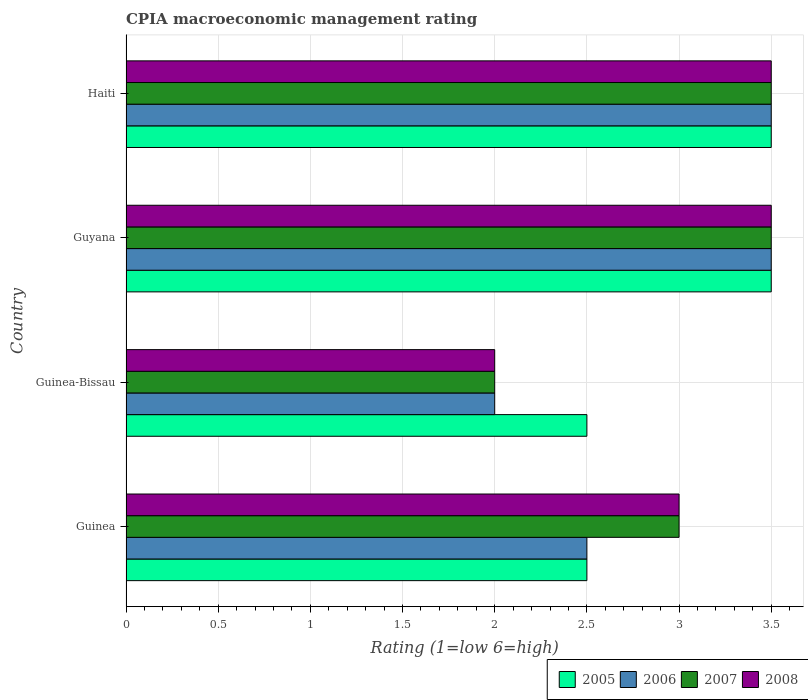How many different coloured bars are there?
Give a very brief answer. 4. Are the number of bars on each tick of the Y-axis equal?
Provide a short and direct response. Yes. How many bars are there on the 1st tick from the top?
Offer a very short reply. 4. How many bars are there on the 3rd tick from the bottom?
Keep it short and to the point. 4. What is the label of the 3rd group of bars from the top?
Provide a short and direct response. Guinea-Bissau. Across all countries, what is the minimum CPIA rating in 2005?
Your answer should be compact. 2.5. In which country was the CPIA rating in 2006 maximum?
Offer a terse response. Guyana. In which country was the CPIA rating in 2008 minimum?
Keep it short and to the point. Guinea-Bissau. What is the total CPIA rating in 2008 in the graph?
Make the answer very short. 12. What is the difference between the CPIA rating in 2005 in Guinea-Bissau and that in Haiti?
Keep it short and to the point. -1. What is the average CPIA rating in 2006 per country?
Provide a succinct answer. 2.88. What is the ratio of the CPIA rating in 2007 in Guinea to that in Guyana?
Provide a succinct answer. 0.86. What is the difference between the highest and the lowest CPIA rating in 2007?
Offer a very short reply. 1.5. In how many countries, is the CPIA rating in 2005 greater than the average CPIA rating in 2005 taken over all countries?
Provide a short and direct response. 2. Is the sum of the CPIA rating in 2007 in Guinea and Guinea-Bissau greater than the maximum CPIA rating in 2005 across all countries?
Your answer should be compact. Yes. Is it the case that in every country, the sum of the CPIA rating in 2005 and CPIA rating in 2007 is greater than the sum of CPIA rating in 2008 and CPIA rating in 2006?
Ensure brevity in your answer.  No. What is the difference between two consecutive major ticks on the X-axis?
Your answer should be very brief. 0.5. Does the graph contain any zero values?
Keep it short and to the point. No. Does the graph contain grids?
Keep it short and to the point. Yes. Where does the legend appear in the graph?
Make the answer very short. Bottom right. What is the title of the graph?
Ensure brevity in your answer.  CPIA macroeconomic management rating. What is the label or title of the Y-axis?
Your answer should be very brief. Country. What is the Rating (1=low 6=high) in 2005 in Guinea?
Make the answer very short. 2.5. What is the Rating (1=low 6=high) of 2006 in Guinea?
Offer a terse response. 2.5. What is the Rating (1=low 6=high) in 2007 in Guinea?
Give a very brief answer. 3. What is the Rating (1=low 6=high) of 2006 in Guinea-Bissau?
Your answer should be very brief. 2. What is the Rating (1=low 6=high) in 2007 in Guinea-Bissau?
Offer a very short reply. 2. What is the Rating (1=low 6=high) in 2005 in Haiti?
Offer a terse response. 3.5. What is the Rating (1=low 6=high) of 2006 in Haiti?
Your answer should be compact. 3.5. What is the Rating (1=low 6=high) of 2008 in Haiti?
Give a very brief answer. 3.5. Across all countries, what is the maximum Rating (1=low 6=high) in 2006?
Provide a succinct answer. 3.5. Across all countries, what is the maximum Rating (1=low 6=high) of 2008?
Offer a terse response. 3.5. Across all countries, what is the minimum Rating (1=low 6=high) in 2006?
Your answer should be compact. 2. Across all countries, what is the minimum Rating (1=low 6=high) in 2007?
Keep it short and to the point. 2. What is the total Rating (1=low 6=high) in 2005 in the graph?
Give a very brief answer. 12. What is the total Rating (1=low 6=high) in 2006 in the graph?
Keep it short and to the point. 11.5. What is the total Rating (1=low 6=high) of 2007 in the graph?
Your response must be concise. 12. What is the difference between the Rating (1=low 6=high) in 2007 in Guinea and that in Guinea-Bissau?
Your response must be concise. 1. What is the difference between the Rating (1=low 6=high) in 2008 in Guinea and that in Guinea-Bissau?
Ensure brevity in your answer.  1. What is the difference between the Rating (1=low 6=high) in 2005 in Guinea and that in Guyana?
Keep it short and to the point. -1. What is the difference between the Rating (1=low 6=high) in 2007 in Guinea and that in Guyana?
Provide a succinct answer. -0.5. What is the difference between the Rating (1=low 6=high) in 2008 in Guinea and that in Guyana?
Your response must be concise. -0.5. What is the difference between the Rating (1=low 6=high) in 2006 in Guinea and that in Haiti?
Provide a succinct answer. -1. What is the difference between the Rating (1=low 6=high) of 2008 in Guinea and that in Haiti?
Ensure brevity in your answer.  -0.5. What is the difference between the Rating (1=low 6=high) in 2006 in Guinea-Bissau and that in Guyana?
Keep it short and to the point. -1.5. What is the difference between the Rating (1=low 6=high) of 2007 in Guinea-Bissau and that in Guyana?
Give a very brief answer. -1.5. What is the difference between the Rating (1=low 6=high) of 2008 in Guinea-Bissau and that in Guyana?
Keep it short and to the point. -1.5. What is the difference between the Rating (1=low 6=high) of 2005 in Guyana and that in Haiti?
Keep it short and to the point. 0. What is the difference between the Rating (1=low 6=high) of 2006 in Guyana and that in Haiti?
Provide a short and direct response. 0. What is the difference between the Rating (1=low 6=high) of 2007 in Guyana and that in Haiti?
Give a very brief answer. 0. What is the difference between the Rating (1=low 6=high) in 2006 in Guinea and the Rating (1=low 6=high) in 2008 in Guinea-Bissau?
Give a very brief answer. 0.5. What is the difference between the Rating (1=low 6=high) in 2007 in Guinea and the Rating (1=low 6=high) in 2008 in Guinea-Bissau?
Your answer should be very brief. 1. What is the difference between the Rating (1=low 6=high) of 2005 in Guinea and the Rating (1=low 6=high) of 2006 in Guyana?
Ensure brevity in your answer.  -1. What is the difference between the Rating (1=low 6=high) in 2005 in Guinea and the Rating (1=low 6=high) in 2007 in Guyana?
Your response must be concise. -1. What is the difference between the Rating (1=low 6=high) of 2006 in Guinea and the Rating (1=low 6=high) of 2008 in Guyana?
Your response must be concise. -1. What is the difference between the Rating (1=low 6=high) in 2005 in Guinea and the Rating (1=low 6=high) in 2008 in Haiti?
Your response must be concise. -1. What is the difference between the Rating (1=low 6=high) in 2006 in Guinea and the Rating (1=low 6=high) in 2007 in Haiti?
Provide a succinct answer. -1. What is the difference between the Rating (1=low 6=high) of 2006 in Guinea and the Rating (1=low 6=high) of 2008 in Haiti?
Give a very brief answer. -1. What is the difference between the Rating (1=low 6=high) in 2007 in Guinea and the Rating (1=low 6=high) in 2008 in Haiti?
Make the answer very short. -0.5. What is the difference between the Rating (1=low 6=high) in 2007 in Guinea-Bissau and the Rating (1=low 6=high) in 2008 in Guyana?
Make the answer very short. -1.5. What is the difference between the Rating (1=low 6=high) of 2005 in Guinea-Bissau and the Rating (1=low 6=high) of 2008 in Haiti?
Your answer should be compact. -1. What is the difference between the Rating (1=low 6=high) of 2007 in Guinea-Bissau and the Rating (1=low 6=high) of 2008 in Haiti?
Make the answer very short. -1.5. What is the average Rating (1=low 6=high) of 2005 per country?
Offer a terse response. 3. What is the average Rating (1=low 6=high) of 2006 per country?
Your answer should be compact. 2.88. What is the average Rating (1=low 6=high) in 2007 per country?
Your answer should be very brief. 3. What is the difference between the Rating (1=low 6=high) of 2006 and Rating (1=low 6=high) of 2007 in Guinea?
Give a very brief answer. -0.5. What is the difference between the Rating (1=low 6=high) of 2006 and Rating (1=low 6=high) of 2008 in Guinea?
Make the answer very short. -0.5. What is the difference between the Rating (1=low 6=high) of 2005 and Rating (1=low 6=high) of 2006 in Guinea-Bissau?
Your answer should be compact. 0.5. What is the difference between the Rating (1=low 6=high) of 2007 and Rating (1=low 6=high) of 2008 in Guinea-Bissau?
Provide a succinct answer. 0. What is the difference between the Rating (1=low 6=high) of 2005 and Rating (1=low 6=high) of 2007 in Guyana?
Give a very brief answer. 0. What is the difference between the Rating (1=low 6=high) in 2005 and Rating (1=low 6=high) in 2008 in Guyana?
Give a very brief answer. 0. What is the difference between the Rating (1=low 6=high) of 2006 and Rating (1=low 6=high) of 2007 in Guyana?
Give a very brief answer. 0. What is the difference between the Rating (1=low 6=high) in 2007 and Rating (1=low 6=high) in 2008 in Guyana?
Provide a short and direct response. 0. What is the difference between the Rating (1=low 6=high) in 2005 and Rating (1=low 6=high) in 2007 in Haiti?
Ensure brevity in your answer.  0. What is the difference between the Rating (1=low 6=high) of 2006 and Rating (1=low 6=high) of 2008 in Haiti?
Your answer should be very brief. 0. What is the ratio of the Rating (1=low 6=high) of 2005 in Guinea to that in Guinea-Bissau?
Make the answer very short. 1. What is the ratio of the Rating (1=low 6=high) in 2008 in Guinea to that in Guinea-Bissau?
Ensure brevity in your answer.  1.5. What is the ratio of the Rating (1=low 6=high) in 2007 in Guinea to that in Guyana?
Your response must be concise. 0.86. What is the ratio of the Rating (1=low 6=high) in 2005 in Guinea to that in Haiti?
Give a very brief answer. 0.71. What is the ratio of the Rating (1=low 6=high) in 2006 in Guinea to that in Haiti?
Ensure brevity in your answer.  0.71. What is the ratio of the Rating (1=low 6=high) of 2007 in Guinea to that in Haiti?
Offer a terse response. 0.86. What is the ratio of the Rating (1=low 6=high) in 2008 in Guinea to that in Haiti?
Give a very brief answer. 0.86. What is the ratio of the Rating (1=low 6=high) of 2005 in Guinea-Bissau to that in Guyana?
Provide a succinct answer. 0.71. What is the ratio of the Rating (1=low 6=high) in 2006 in Guinea-Bissau to that in Guyana?
Your response must be concise. 0.57. What is the ratio of the Rating (1=low 6=high) in 2005 in Guinea-Bissau to that in Haiti?
Offer a terse response. 0.71. What is the ratio of the Rating (1=low 6=high) in 2006 in Guinea-Bissau to that in Haiti?
Provide a succinct answer. 0.57. What is the ratio of the Rating (1=low 6=high) of 2007 in Guinea-Bissau to that in Haiti?
Your response must be concise. 0.57. What is the difference between the highest and the second highest Rating (1=low 6=high) in 2005?
Your answer should be compact. 0. What is the difference between the highest and the second highest Rating (1=low 6=high) of 2006?
Ensure brevity in your answer.  0. What is the difference between the highest and the second highest Rating (1=low 6=high) in 2007?
Provide a short and direct response. 0. What is the difference between the highest and the second highest Rating (1=low 6=high) in 2008?
Your answer should be very brief. 0. What is the difference between the highest and the lowest Rating (1=low 6=high) of 2005?
Your answer should be very brief. 1. What is the difference between the highest and the lowest Rating (1=low 6=high) in 2006?
Give a very brief answer. 1.5. What is the difference between the highest and the lowest Rating (1=low 6=high) in 2008?
Your answer should be very brief. 1.5. 